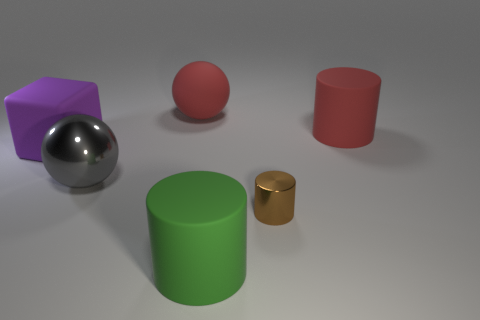Subtract all blue spheres. Subtract all blue blocks. How many spheres are left? 2 Add 1 tiny purple metal blocks. How many objects exist? 7 Subtract all blocks. How many objects are left? 5 Add 3 large gray metal things. How many large gray metal things exist? 4 Subtract 0 purple cylinders. How many objects are left? 6 Subtract all metallic cylinders. Subtract all small cylinders. How many objects are left? 4 Add 5 green matte cylinders. How many green matte cylinders are left? 6 